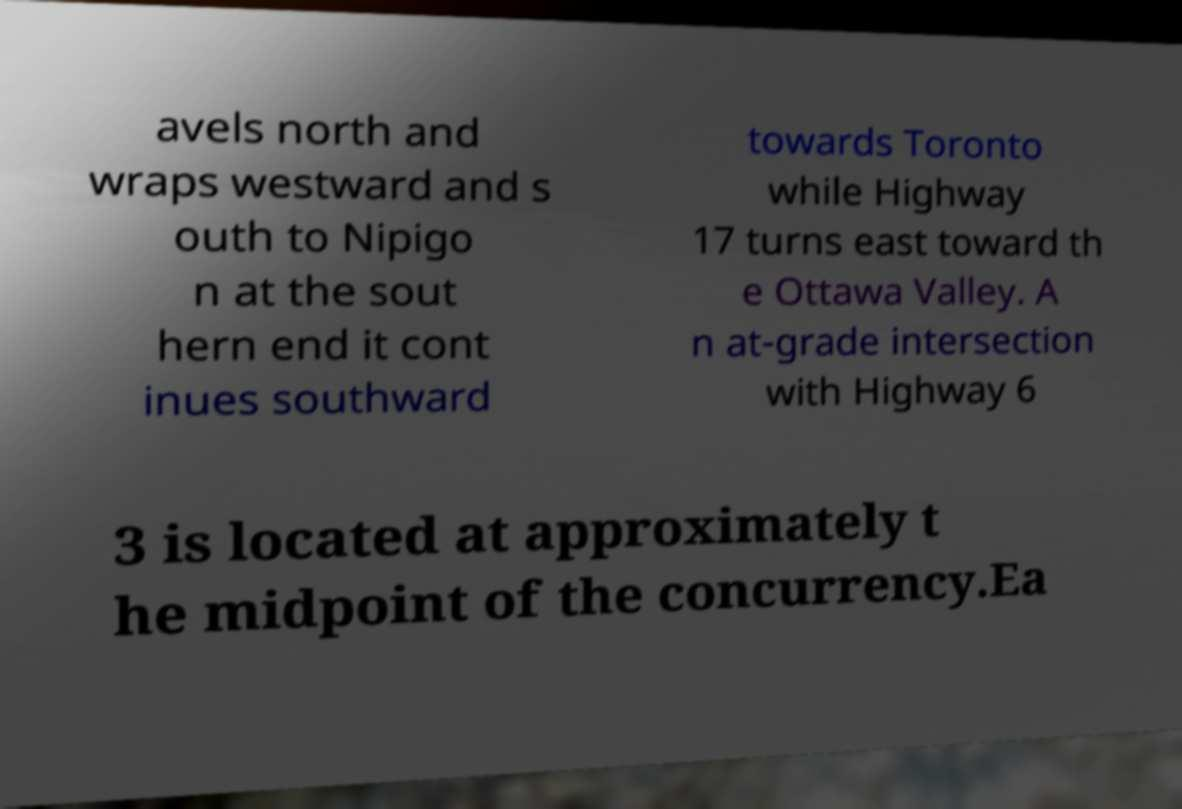There's text embedded in this image that I need extracted. Can you transcribe it verbatim? avels north and wraps westward and s outh to Nipigo n at the sout hern end it cont inues southward towards Toronto while Highway 17 turns east toward th e Ottawa Valley. A n at-grade intersection with Highway 6 3 is located at approximately t he midpoint of the concurrency.Ea 